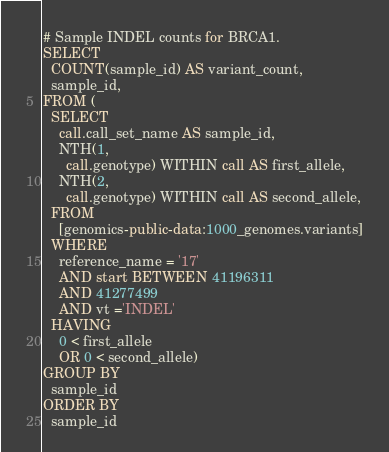<code> <loc_0><loc_0><loc_500><loc_500><_SQL_># Sample INDEL counts for BRCA1.
SELECT
  COUNT(sample_id) AS variant_count,
  sample_id,
FROM (
  SELECT
    call.call_set_name AS sample_id,
    NTH(1,
      call.genotype) WITHIN call AS first_allele,
    NTH(2,
      call.genotype) WITHIN call AS second_allele,
  FROM
    [genomics-public-data:1000_genomes.variants]
  WHERE
    reference_name = '17'
    AND start BETWEEN 41196311
    AND 41277499
    AND vt ='INDEL'
  HAVING
    0 < first_allele
    OR 0 < second_allele)
GROUP BY
  sample_id
ORDER BY
  sample_id
</code> 